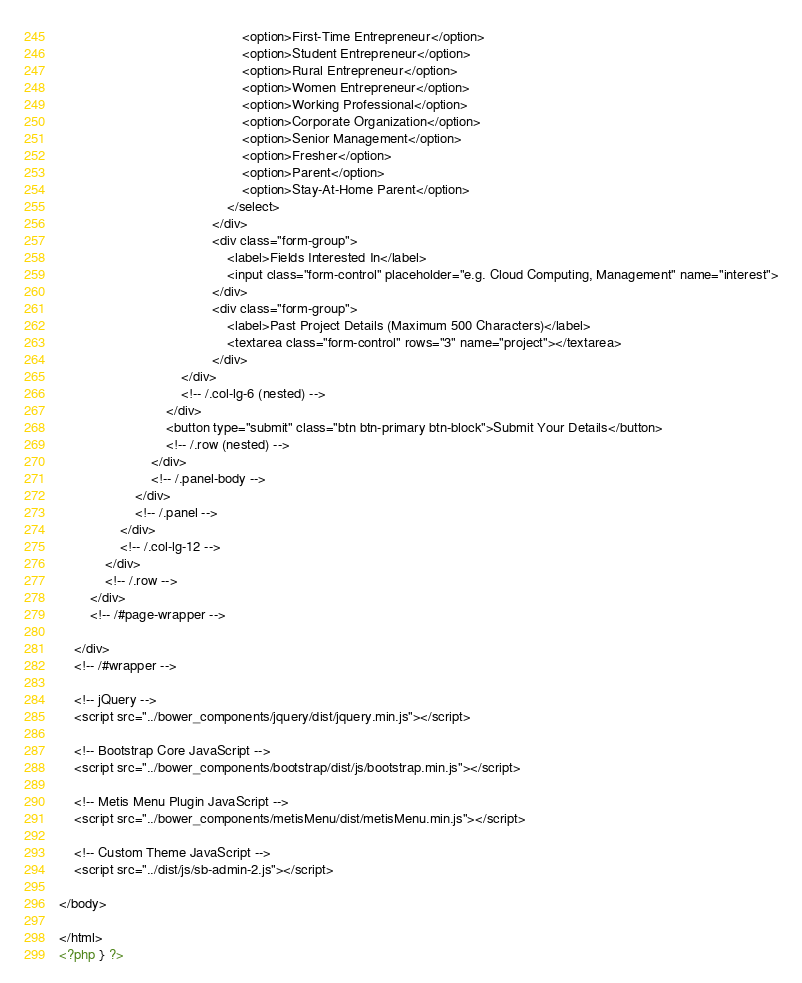Convert code to text. <code><loc_0><loc_0><loc_500><loc_500><_PHP_>                                                <option>First-Time Entrepreneur</option>
                                                <option>Student Entrepreneur</option>
                                                <option>Rural Entrepreneur</option>
                                                <option>Women Entrepreneur</option>
                                                <option>Working Professional</option>
                                                <option>Corporate Organization</option>
                                                <option>Senior Management</option>
                                                <option>Fresher</option>
                                                <option>Parent</option>
                                                <option>Stay-At-Home Parent</option>
                                            </select>
                                        </div>
                                        <div class="form-group">
                                            <label>Fields Interested In</label>
                                            <input class="form-control" placeholder="e.g. Cloud Computing, Management" name="interest">
                                        </div>                                        
                                        <div class="form-group">
                                            <label>Past Project Details (Maximum 500 Characters)</label>
                                            <textarea class="form-control" rows="3" name="project"></textarea>
                                        </div>
                                </div>
                                <!-- /.col-lg-6 (nested) -->
                            </div>
                            <button type="submit" class="btn btn-primary btn-block">Submit Your Details</button>
                            <!-- /.row (nested) -->
                        </div>
                        <!-- /.panel-body -->
                    </div>
                    <!-- /.panel -->
                </div>
                <!-- /.col-lg-12 -->
            </div>
            <!-- /.row -->
        </div>
        <!-- /#page-wrapper -->

    </div>
    <!-- /#wrapper -->

    <!-- jQuery -->
    <script src="../bower_components/jquery/dist/jquery.min.js"></script>

    <!-- Bootstrap Core JavaScript -->
    <script src="../bower_components/bootstrap/dist/js/bootstrap.min.js"></script>

    <!-- Metis Menu Plugin JavaScript -->
    <script src="../bower_components/metisMenu/dist/metisMenu.min.js"></script>

    <!-- Custom Theme JavaScript -->
    <script src="../dist/js/sb-admin-2.js"></script>

</body>

</html>
<?php } ?></code> 